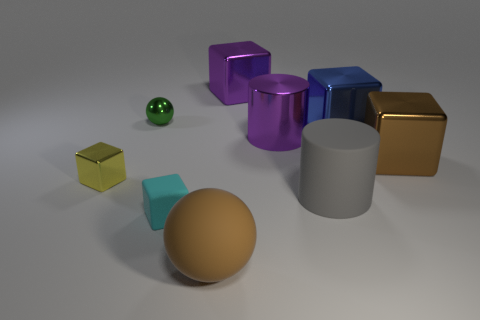Add 1 gray objects. How many objects exist? 10 Subtract all brown balls. How many balls are left? 1 Subtract all small cyan blocks. How many blocks are left? 4 Subtract 1 cubes. How many cubes are left? 4 Subtract 1 purple cubes. How many objects are left? 8 Subtract all balls. How many objects are left? 7 Subtract all yellow cylinders. Subtract all gray cubes. How many cylinders are left? 2 Subtract all brown cubes. How many green balls are left? 1 Subtract all small cyan things. Subtract all purple cylinders. How many objects are left? 7 Add 4 green objects. How many green objects are left? 5 